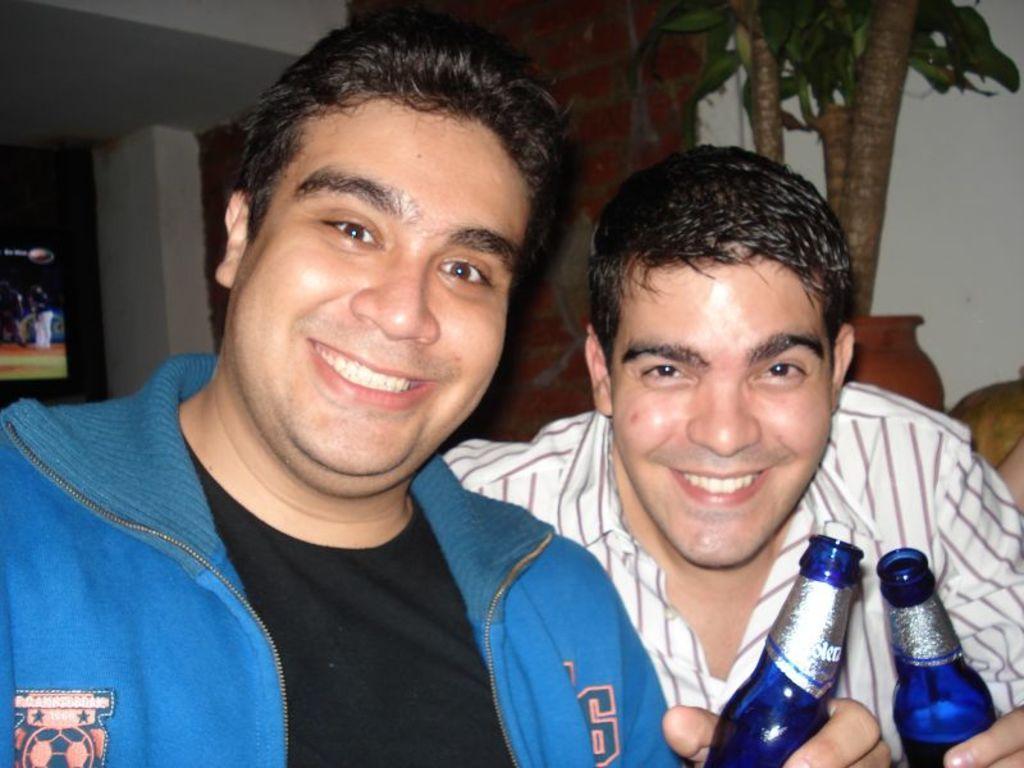How would you summarize this image in a sentence or two? This picture consists of a two person, holding a two bottles in their hand and having a smile on their face. The background is white in color. In the top right, a houseplant is there. In the left, a monitor is visible. This image is taken inside a house. 